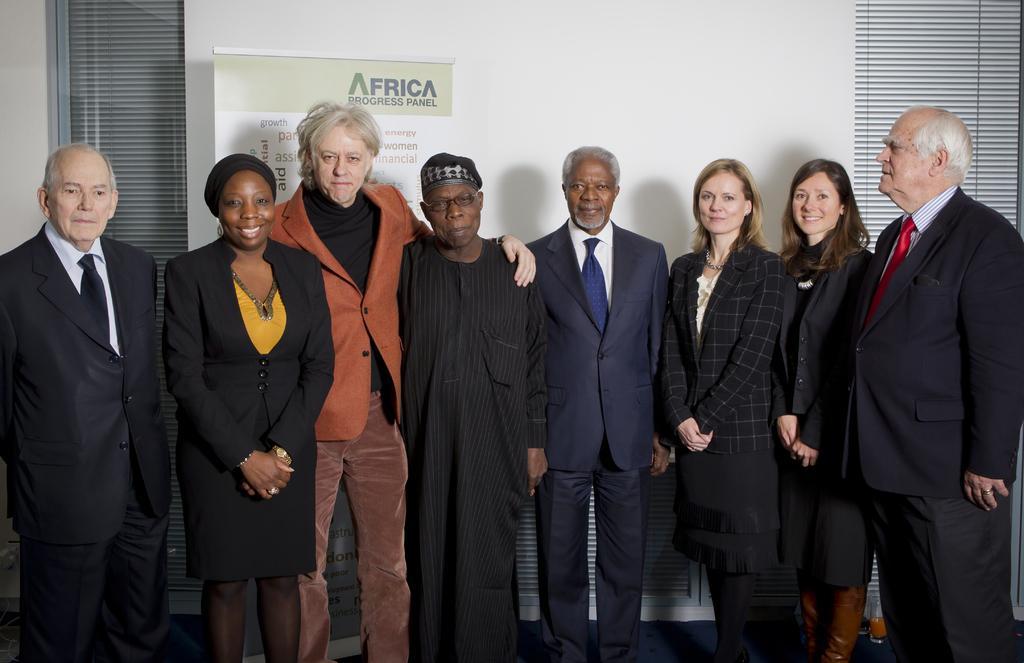In one or two sentences, can you explain what this image depicts? In this image we can see group of persons standing on the floor. In the background we can see curtain, windows, advertisement and wall. 